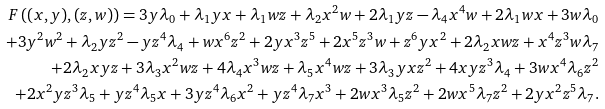<formula> <loc_0><loc_0><loc_500><loc_500>F \left ( ( x , y ) , ( z , w ) \right ) = 3 y \lambda _ { 0 } + \lambda _ { 1 } y x + \lambda _ { 1 } w z + \lambda _ { 2 } x ^ { 2 } w + 2 \lambda _ { 1 } y z - \lambda _ { 4 } x ^ { 4 } w + 2 \lambda _ { 1 } w x + 3 w \lambda _ { 0 } \\ \quad + 3 y ^ { 2 } w ^ { 2 } + \lambda _ { 2 } y z ^ { 2 } - y z ^ { 4 } \lambda _ { 4 } + w x ^ { 6 } z ^ { 2 } + 2 y x ^ { 3 } z ^ { 5 } + 2 x ^ { 5 } z ^ { 3 } w + z ^ { 6 } y x ^ { 2 } + 2 \lambda _ { 2 } x w z + x ^ { 4 } z ^ { 3 } w \lambda _ { 7 } \\ \quad + 2 \lambda _ { 2 } x y z + 3 \lambda _ { 3 } x ^ { 2 } w z + 4 \lambda _ { 4 } x ^ { 3 } w z + \lambda _ { 5 } x ^ { 4 } w z + 3 \lambda _ { 3 } y x z ^ { 2 } + 4 x y z ^ { 3 } \lambda _ { 4 } + 3 w x ^ { 4 } \lambda _ { 6 } z ^ { 2 } \\ \quad + 2 x ^ { 2 } y z ^ { 3 } \lambda _ { 5 } + y z ^ { 4 } \lambda _ { 5 } x + 3 y z ^ { 4 } \lambda _ { 6 } x ^ { 2 } + y z ^ { 4 } \lambda _ { 7 } x ^ { 3 } + 2 w x ^ { 3 } \lambda _ { 5 } z ^ { 2 } + 2 w x ^ { 5 } \lambda _ { 7 } z ^ { 2 } + 2 y x ^ { 2 } z ^ { 5 } \lambda _ { 7 } .</formula> 